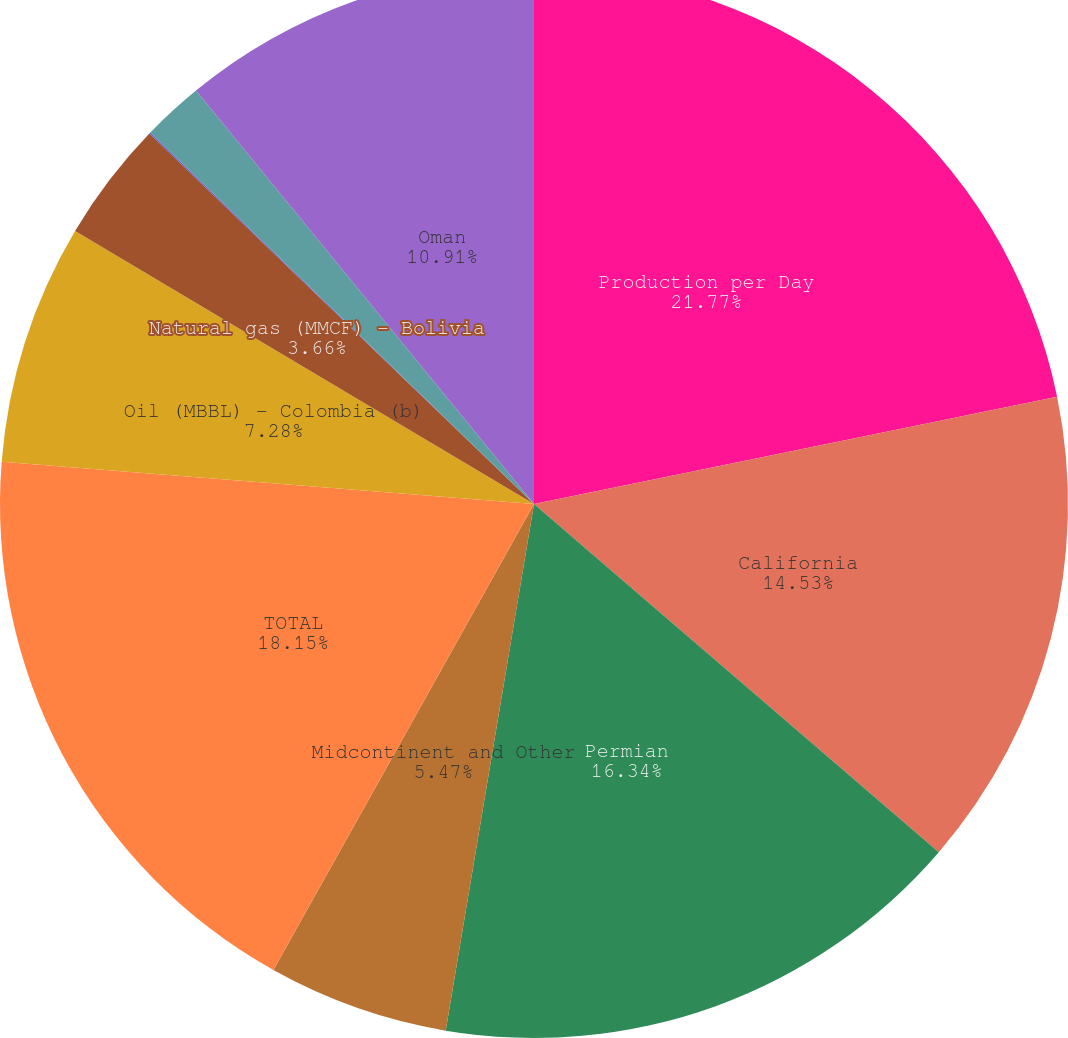<chart> <loc_0><loc_0><loc_500><loc_500><pie_chart><fcel>Production per Day<fcel>California<fcel>Permian<fcel>Midcontinent and Other<fcel>TOTAL<fcel>Oil (MBBL) - Colombia (b)<fcel>Natural gas (MMCF) - Bolivia<fcel>Bahrain<fcel>Dolphin<fcel>Oman<nl><fcel>21.78%<fcel>14.53%<fcel>16.34%<fcel>5.47%<fcel>18.15%<fcel>7.28%<fcel>3.66%<fcel>0.04%<fcel>1.85%<fcel>10.91%<nl></chart> 